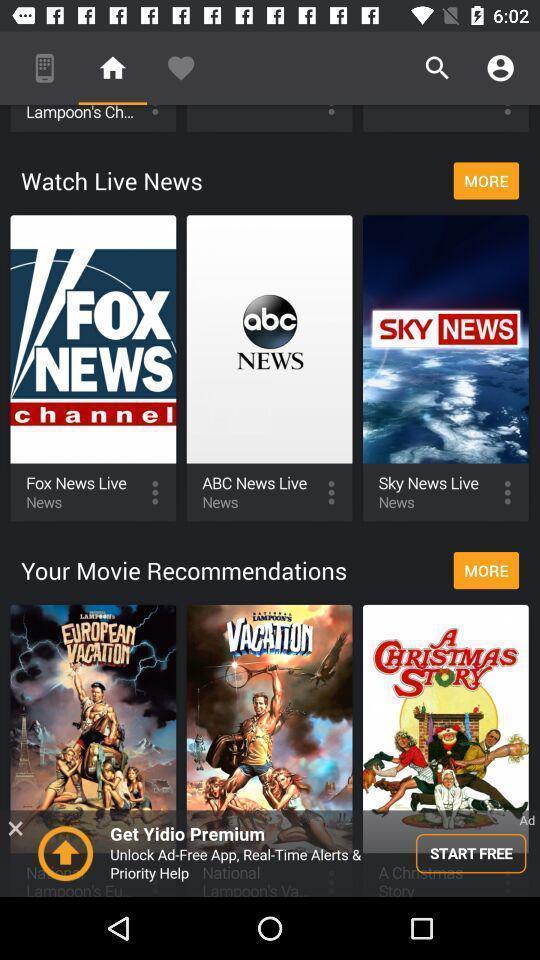Describe the visual elements of this screenshot. Page shows the live news and movie recommendations on app. 